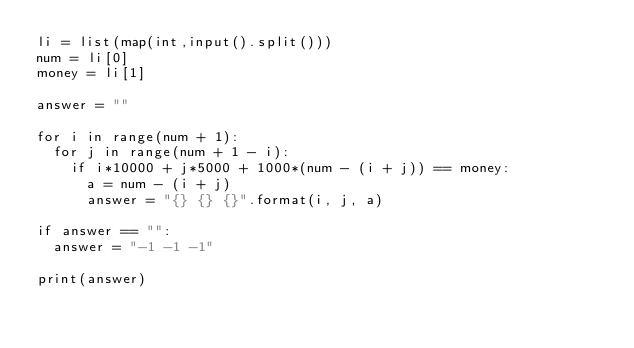Convert code to text. <code><loc_0><loc_0><loc_500><loc_500><_Python_>li = list(map(int,input().split()))
num = li[0]
money = li[1]

answer = ""

for i in range(num + 1):
  for j in range(num + 1 - i):
    if i*10000 + j*5000 + 1000*(num - (i + j)) == money:
      a = num - (i + j)
      answer = "{} {} {}".format(i, j, a)

if answer == "":
  answer = "-1 -1 -1"

print(answer)</code> 